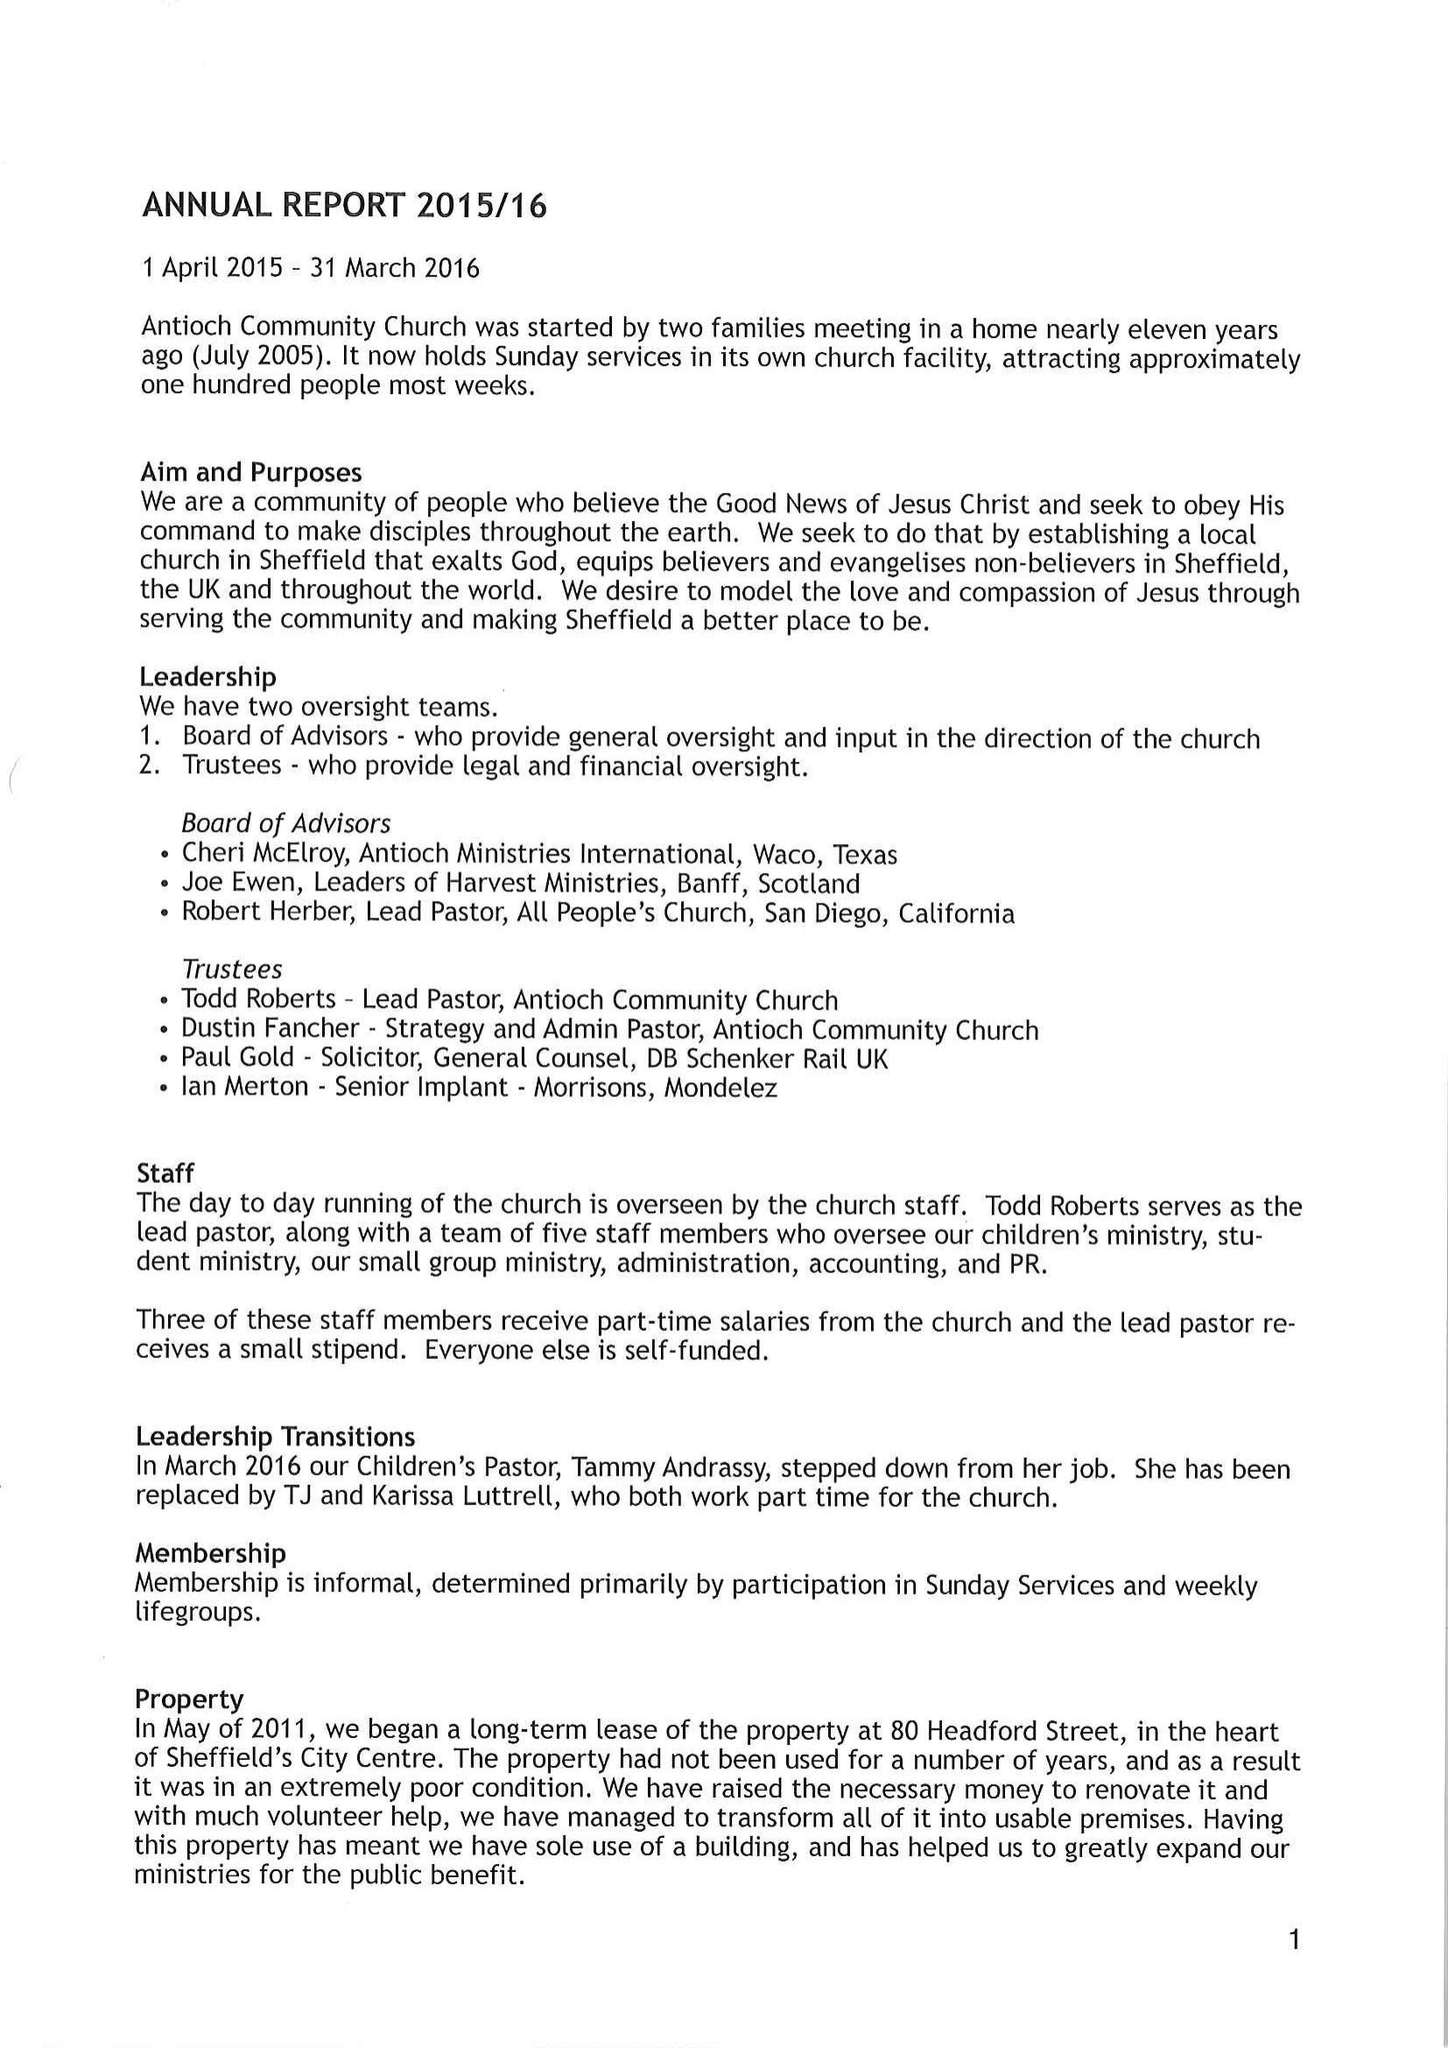What is the value for the address__post_town?
Answer the question using a single word or phrase. None 